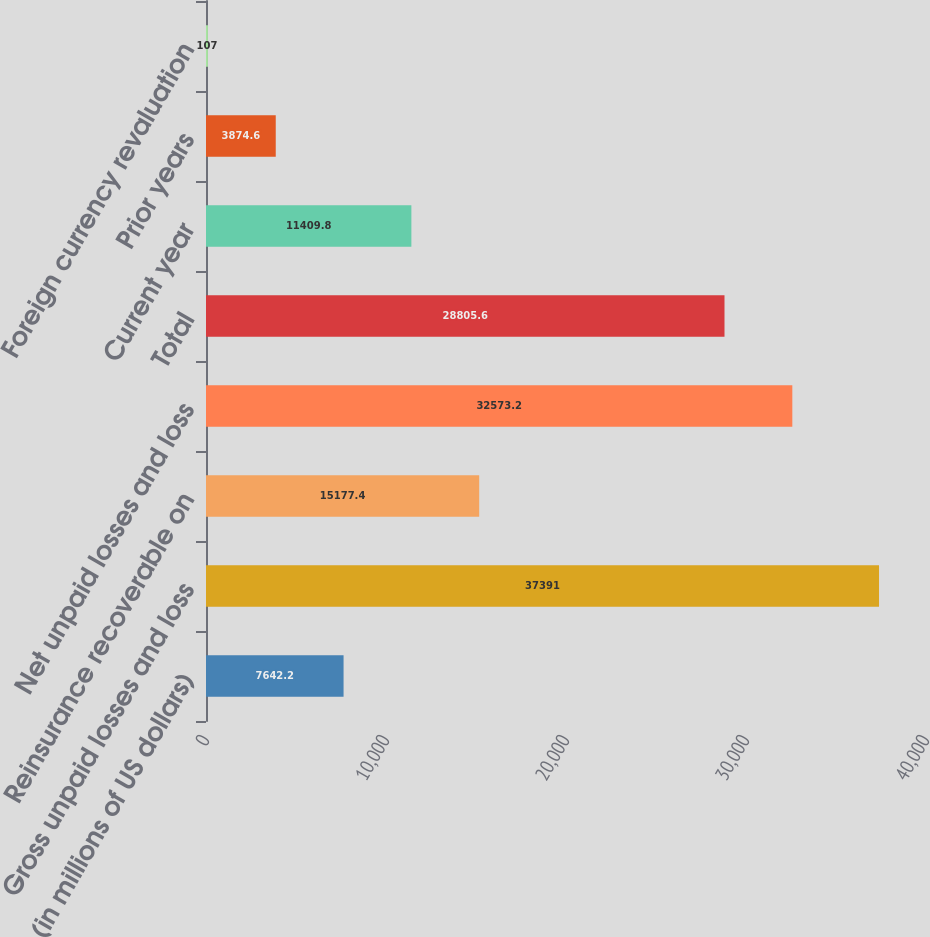<chart> <loc_0><loc_0><loc_500><loc_500><bar_chart><fcel>(in millions of US dollars)<fcel>Gross unpaid losses and loss<fcel>Reinsurance recoverable on<fcel>Net unpaid losses and loss<fcel>Total<fcel>Current year<fcel>Prior years<fcel>Foreign currency revaluation<nl><fcel>7642.2<fcel>37391<fcel>15177.4<fcel>32573.2<fcel>28805.6<fcel>11409.8<fcel>3874.6<fcel>107<nl></chart> 